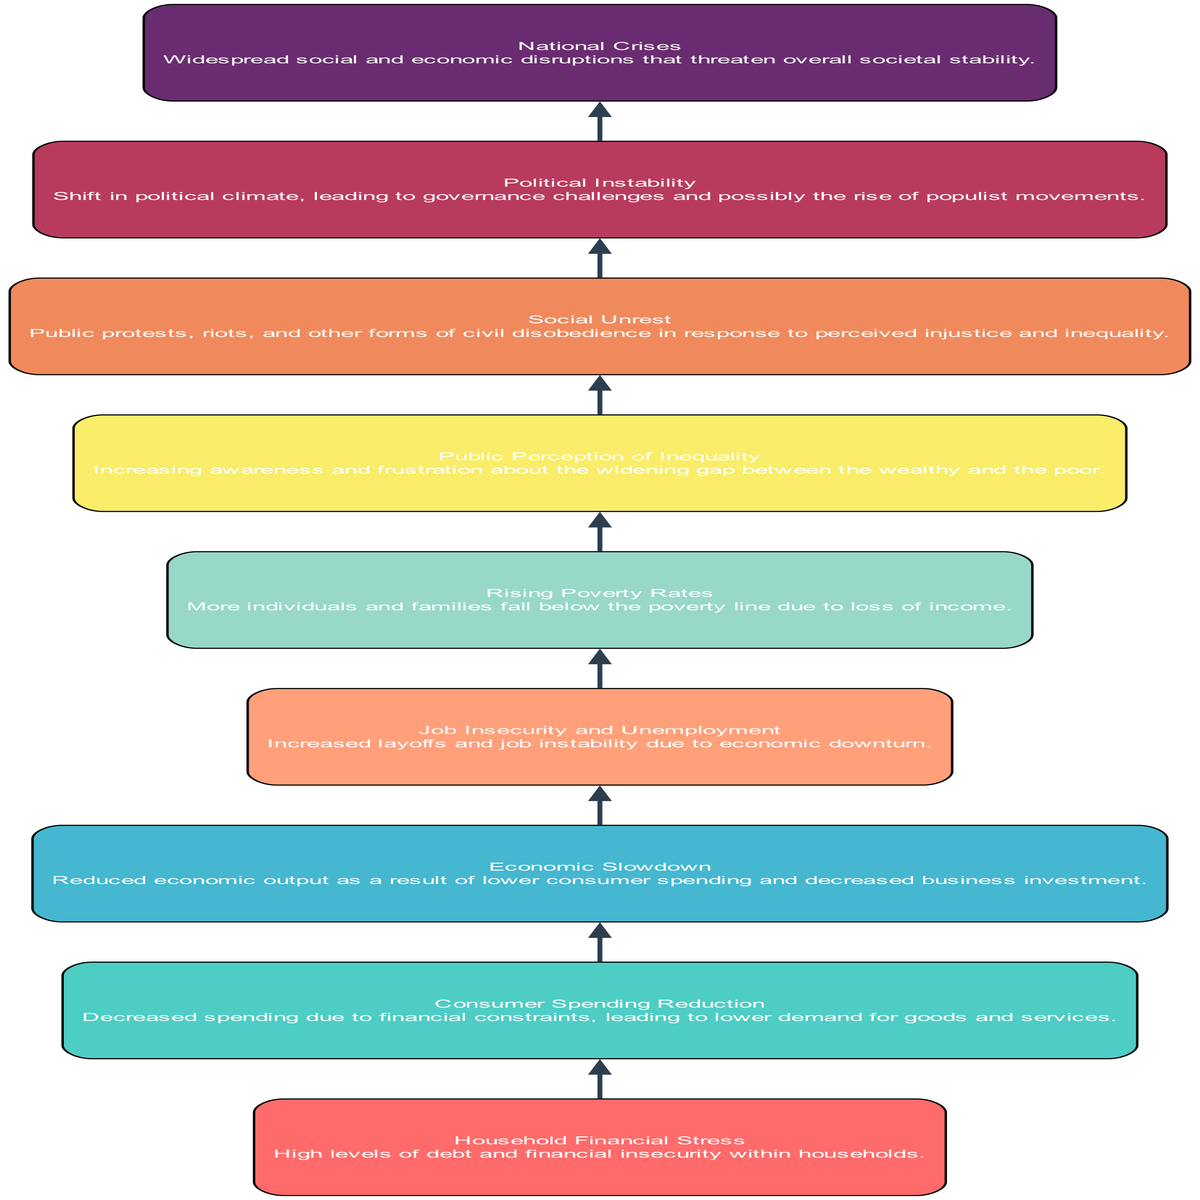What is the first element in the flow? The first element listed at the bottom of the flow chart is "Household Financial Stress," which indicates the starting point of the progression.
Answer: Household Financial Stress How many nodes are in the diagram? The total number of nodes, which are distinct elements in the flow, is counted from "Household Financial Stress" to "National Crises." There are nine nodes in total.
Answer: 9 What is the last element in the flow? The last element at the top of the flow chart is "National Crises," which signifies the endpoint of the cascade of events.
Answer: National Crises Which elements lead to "Job Insecurity and Unemployment"? "Economic Slowdown" directly leads to "Job Insecurity and Unemployment," showing the sequential relationship between decreasing economic performance and employment conditions.
Answer: Economic Slowdown What are the two elements that directly precede "Social Unrest"? The two elements that lead directly into "Social Unrest" are "Public Perception of Inequality" and "Rising Poverty Rates." Both conditions contribute to the emergence of social unrest.
Answer: Public Perception of Inequality, Rising Poverty Rates What is the relationship between "Consumer Spending Reduction" and "Economic Slowdown"? "Consumer Spending Reduction" is an initial cause that leads to "Economic Slowdown." This relationship shows how reduced spending impacts economic activity, creating a domino effect.
Answer: Consumer Spending Reduction ➔ Economic Slowdown What element follows "Rising Poverty Rates" in the flow? The next element that follows "Rising Poverty Rates" in the sequence is "Social Unrest," indicating that as poverty rises, unrest tends to increase.
Answer: Social Unrest How does "Public Perception of Inequality" influence "Political Instability"? "Public Perception of Inequality" affects "Political Instability" by creating a climate of discontent and pressure on governance, which may lead to significant political shifts or unrest.
Answer: Public Perception of Inequality ➔ Political Instability What are the immediate consequences of "Household Financial Stress"? The immediate consequence of "Household Financial Stress" is "Consumer Spending Reduction," as households facing financial issues tend to cut back on their spending.
Answer: Consumer Spending Reduction 